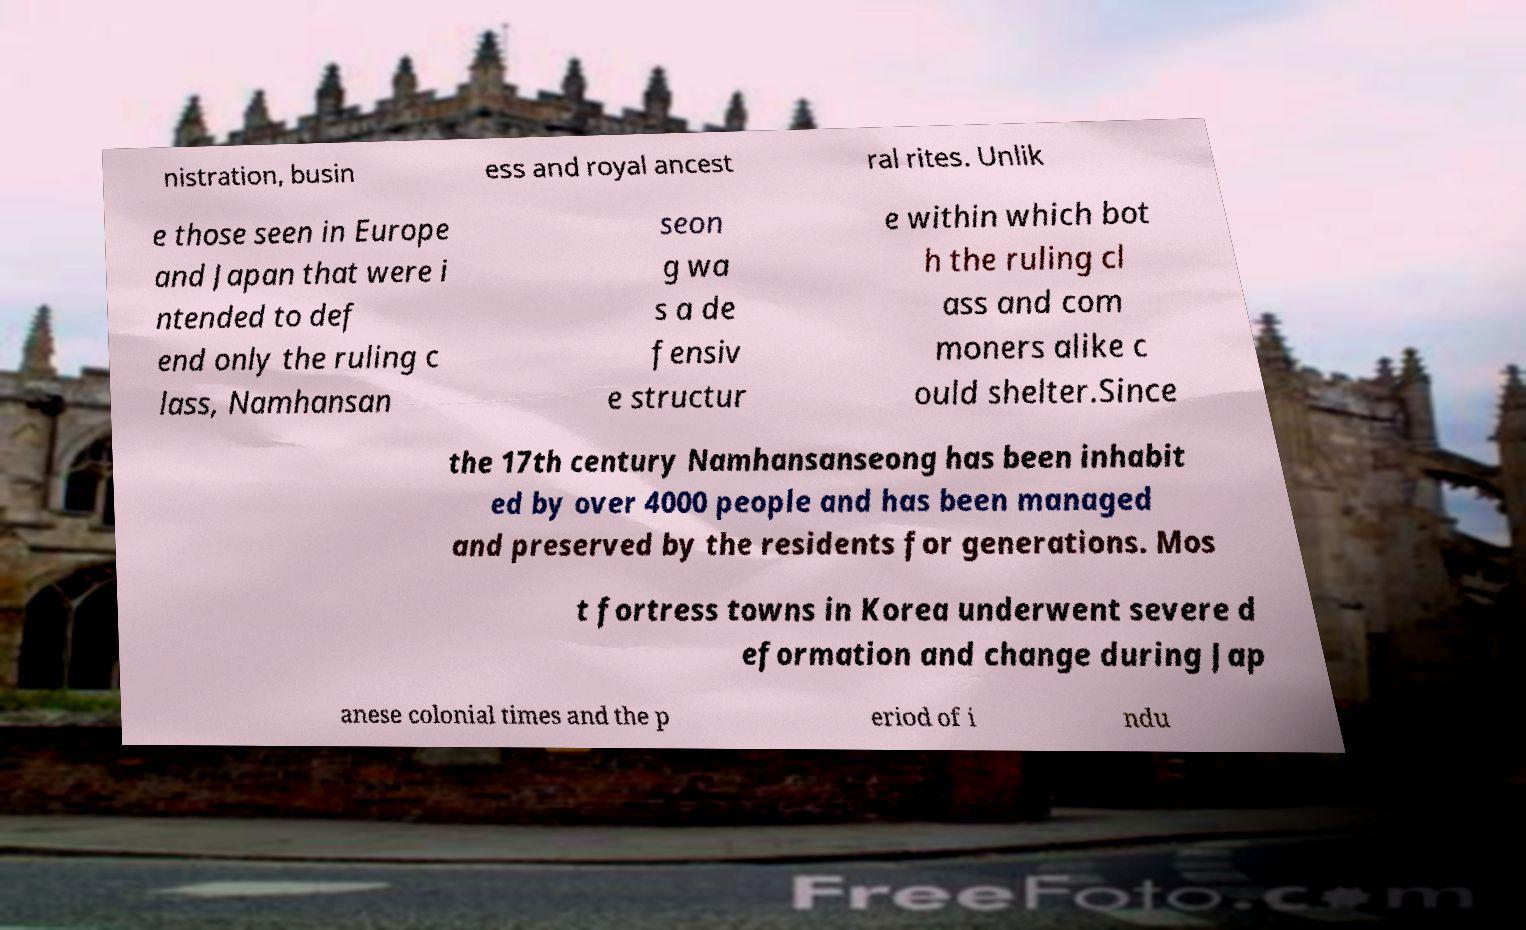Please read and relay the text visible in this image. What does it say? nistration, busin ess and royal ancest ral rites. Unlik e those seen in Europe and Japan that were i ntended to def end only the ruling c lass, Namhansan seon g wa s a de fensiv e structur e within which bot h the ruling cl ass and com moners alike c ould shelter.Since the 17th century Namhansanseong has been inhabit ed by over 4000 people and has been managed and preserved by the residents for generations. Mos t fortress towns in Korea underwent severe d eformation and change during Jap anese colonial times and the p eriod of i ndu 